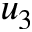<formula> <loc_0><loc_0><loc_500><loc_500>u _ { 3 }</formula> 